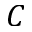Convert formula to latex. <formula><loc_0><loc_0><loc_500><loc_500>C</formula> 